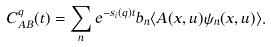<formula> <loc_0><loc_0><loc_500><loc_500>C _ { A B } ^ { q } ( t ) = \sum _ { n } e ^ { - s _ { i } ( q ) t } b _ { n } \langle A ( x , { u } ) \psi _ { n } ( x , { u } ) \rangle .</formula> 